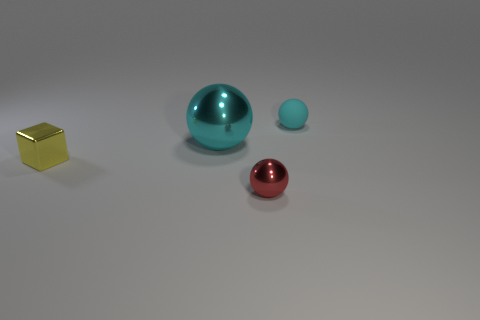Subtract all small cyan matte balls. How many balls are left? 2 Add 4 large cyan metallic spheres. How many objects exist? 8 Subtract all red balls. How many balls are left? 2 Subtract all blocks. How many objects are left? 3 Subtract 1 spheres. How many spheres are left? 2 Subtract all purple cylinders. How many brown blocks are left? 0 Add 4 small cyan things. How many small cyan things are left? 5 Add 2 cyan rubber balls. How many cyan rubber balls exist? 3 Subtract 0 red blocks. How many objects are left? 4 Subtract all red blocks. Subtract all cyan balls. How many blocks are left? 1 